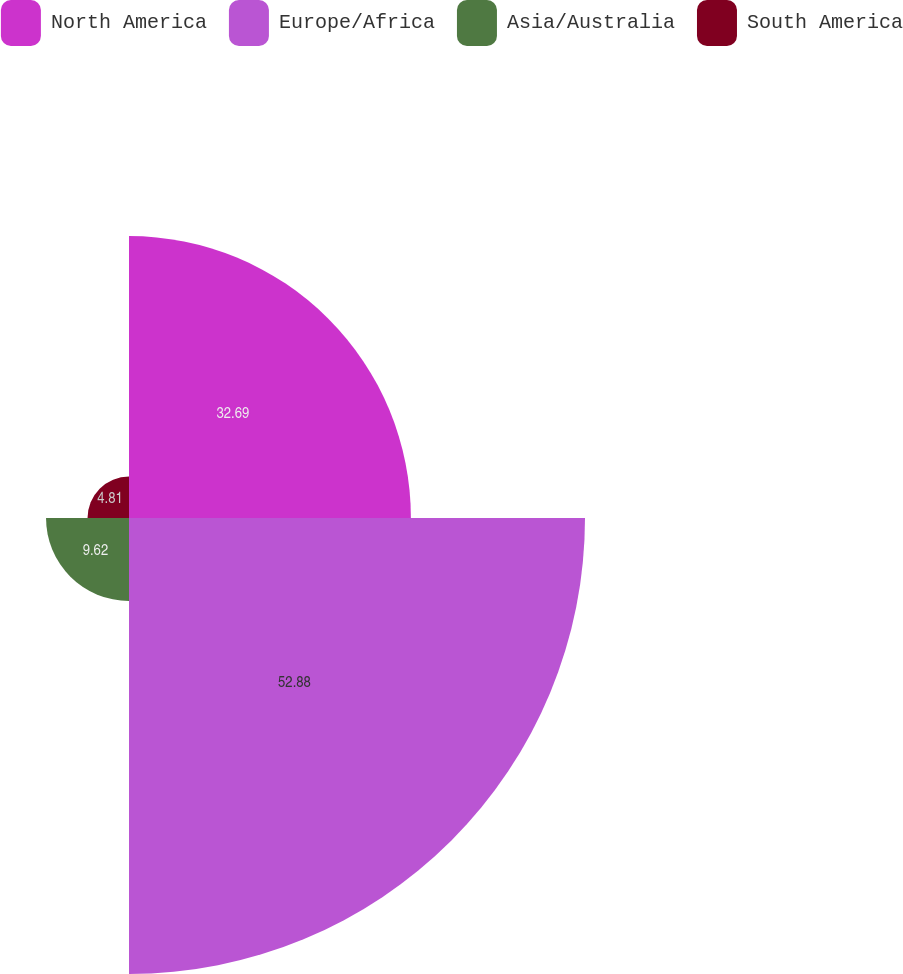Convert chart to OTSL. <chart><loc_0><loc_0><loc_500><loc_500><pie_chart><fcel>North America<fcel>Europe/Africa<fcel>Asia/Australia<fcel>South America<nl><fcel>32.69%<fcel>52.88%<fcel>9.62%<fcel>4.81%<nl></chart> 